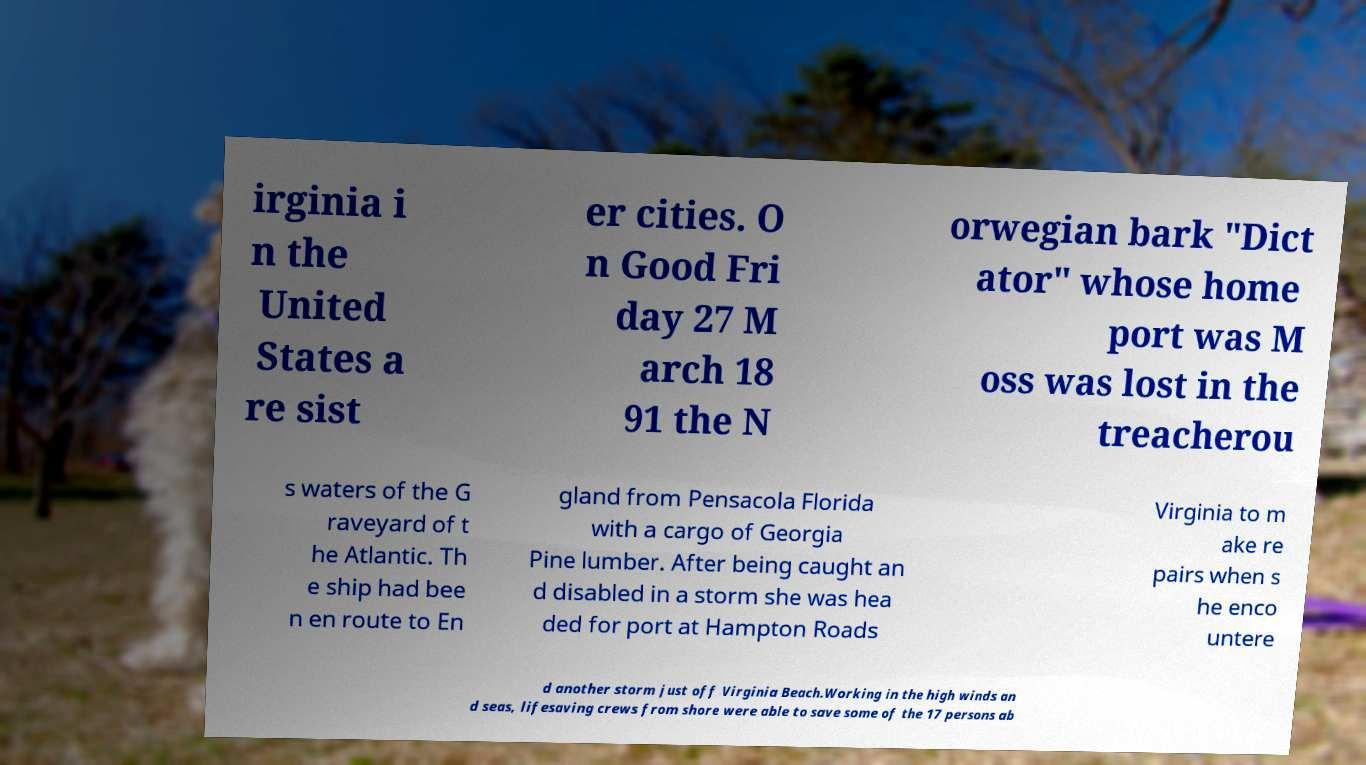There's text embedded in this image that I need extracted. Can you transcribe it verbatim? irginia i n the United States a re sist er cities. O n Good Fri day 27 M arch 18 91 the N orwegian bark "Dict ator" whose home port was M oss was lost in the treacherou s waters of the G raveyard of t he Atlantic. Th e ship had bee n en route to En gland from Pensacola Florida with a cargo of Georgia Pine lumber. After being caught an d disabled in a storm she was hea ded for port at Hampton Roads Virginia to m ake re pairs when s he enco untere d another storm just off Virginia Beach.Working in the high winds an d seas, lifesaving crews from shore were able to save some of the 17 persons ab 